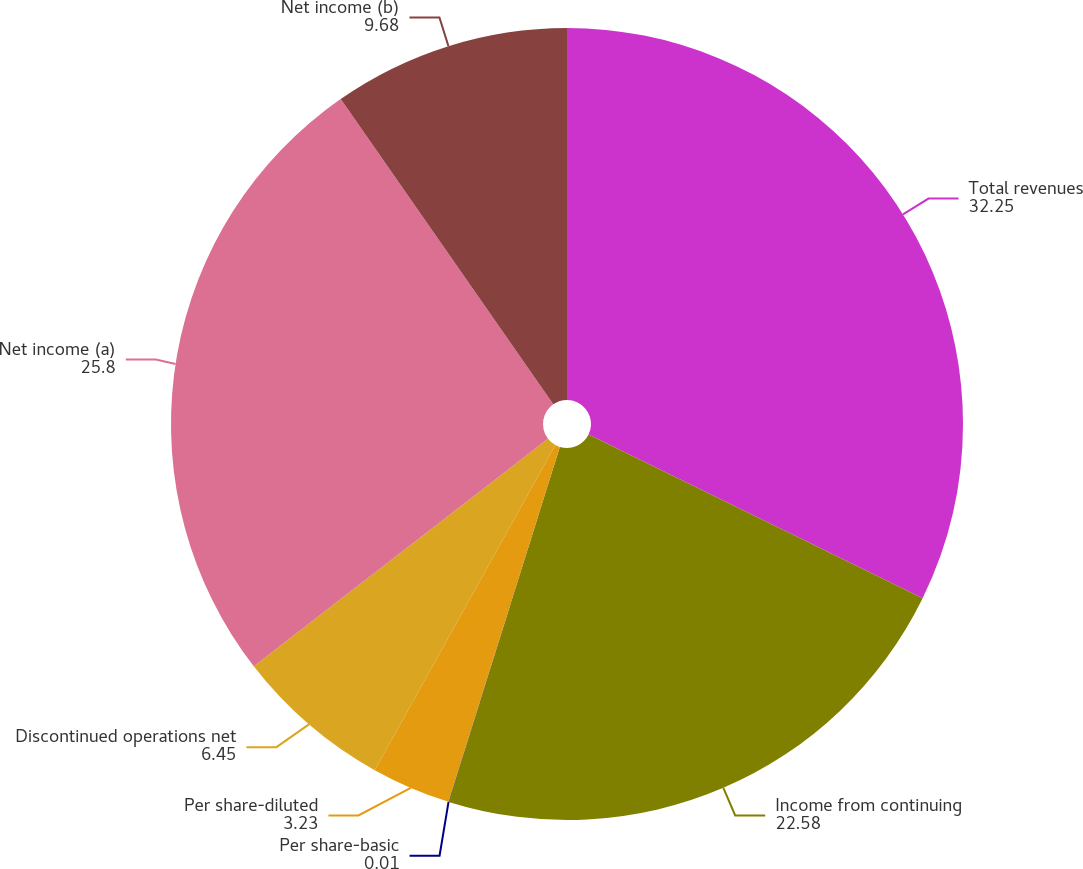<chart> <loc_0><loc_0><loc_500><loc_500><pie_chart><fcel>Total revenues<fcel>Income from continuing<fcel>Per share-basic<fcel>Per share-diluted<fcel>Discontinued operations net<fcel>Net income (a)<fcel>Net income (b)<nl><fcel>32.25%<fcel>22.58%<fcel>0.01%<fcel>3.23%<fcel>6.45%<fcel>25.8%<fcel>9.68%<nl></chart> 